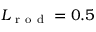<formula> <loc_0><loc_0><loc_500><loc_500>L _ { r o d } = 0 . 5</formula> 